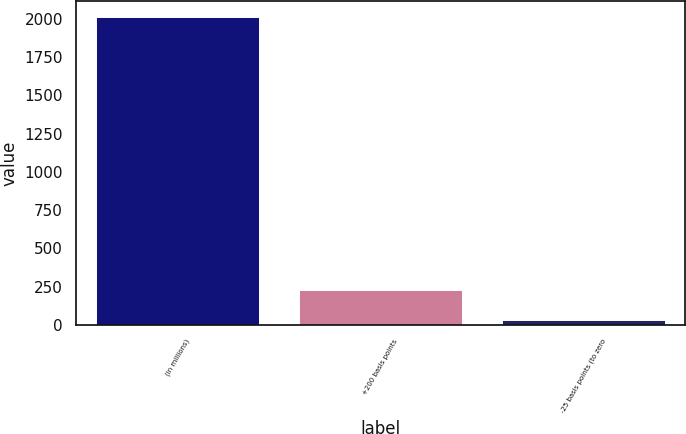Convert chart to OTSL. <chart><loc_0><loc_0><loc_500><loc_500><bar_chart><fcel>(in millions)<fcel>+200 basis points<fcel>-25 basis points (to zero<nl><fcel>2014<fcel>230.2<fcel>32<nl></chart> 